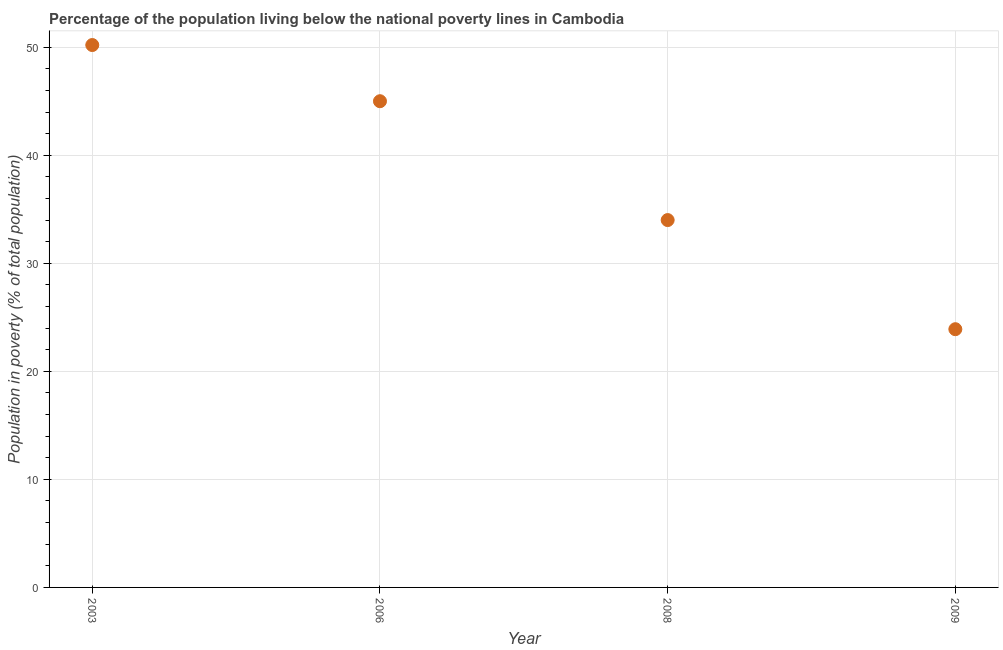What is the percentage of population living below poverty line in 2009?
Offer a very short reply. 23.9. Across all years, what is the maximum percentage of population living below poverty line?
Offer a very short reply. 50.2. Across all years, what is the minimum percentage of population living below poverty line?
Your response must be concise. 23.9. What is the sum of the percentage of population living below poverty line?
Offer a very short reply. 153.1. What is the average percentage of population living below poverty line per year?
Keep it short and to the point. 38.27. What is the median percentage of population living below poverty line?
Give a very brief answer. 39.5. Do a majority of the years between 2003 and 2006 (inclusive) have percentage of population living below poverty line greater than 4 %?
Keep it short and to the point. Yes. What is the ratio of the percentage of population living below poverty line in 2003 to that in 2008?
Your response must be concise. 1.48. Is the percentage of population living below poverty line in 2006 less than that in 2008?
Provide a short and direct response. No. Is the difference between the percentage of population living below poverty line in 2006 and 2009 greater than the difference between any two years?
Your answer should be compact. No. What is the difference between the highest and the second highest percentage of population living below poverty line?
Your answer should be compact. 5.2. Is the sum of the percentage of population living below poverty line in 2006 and 2009 greater than the maximum percentage of population living below poverty line across all years?
Offer a terse response. Yes. What is the difference between the highest and the lowest percentage of population living below poverty line?
Keep it short and to the point. 26.3. In how many years, is the percentage of population living below poverty line greater than the average percentage of population living below poverty line taken over all years?
Ensure brevity in your answer.  2. Does the percentage of population living below poverty line monotonically increase over the years?
Keep it short and to the point. No. How many dotlines are there?
Your answer should be compact. 1. How many years are there in the graph?
Your answer should be very brief. 4. What is the difference between two consecutive major ticks on the Y-axis?
Your answer should be very brief. 10. Are the values on the major ticks of Y-axis written in scientific E-notation?
Provide a short and direct response. No. Does the graph contain any zero values?
Offer a terse response. No. What is the title of the graph?
Ensure brevity in your answer.  Percentage of the population living below the national poverty lines in Cambodia. What is the label or title of the Y-axis?
Your answer should be very brief. Population in poverty (% of total population). What is the Population in poverty (% of total population) in 2003?
Provide a succinct answer. 50.2. What is the Population in poverty (% of total population) in 2008?
Offer a terse response. 34. What is the Population in poverty (% of total population) in 2009?
Keep it short and to the point. 23.9. What is the difference between the Population in poverty (% of total population) in 2003 and 2008?
Offer a very short reply. 16.2. What is the difference between the Population in poverty (% of total population) in 2003 and 2009?
Make the answer very short. 26.3. What is the difference between the Population in poverty (% of total population) in 2006 and 2008?
Ensure brevity in your answer.  11. What is the difference between the Population in poverty (% of total population) in 2006 and 2009?
Make the answer very short. 21.1. What is the ratio of the Population in poverty (% of total population) in 2003 to that in 2006?
Offer a terse response. 1.12. What is the ratio of the Population in poverty (% of total population) in 2003 to that in 2008?
Offer a terse response. 1.48. What is the ratio of the Population in poverty (% of total population) in 2003 to that in 2009?
Give a very brief answer. 2.1. What is the ratio of the Population in poverty (% of total population) in 2006 to that in 2008?
Provide a succinct answer. 1.32. What is the ratio of the Population in poverty (% of total population) in 2006 to that in 2009?
Keep it short and to the point. 1.88. What is the ratio of the Population in poverty (% of total population) in 2008 to that in 2009?
Offer a very short reply. 1.42. 